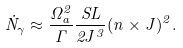Convert formula to latex. <formula><loc_0><loc_0><loc_500><loc_500>\dot { N } _ { \gamma } \approx \frac { \Omega _ { a } ^ { 2 } } { \Gamma } \frac { S L } { 2 J ^ { 3 } } ( { n } \times { J } ) ^ { 2 } .</formula> 